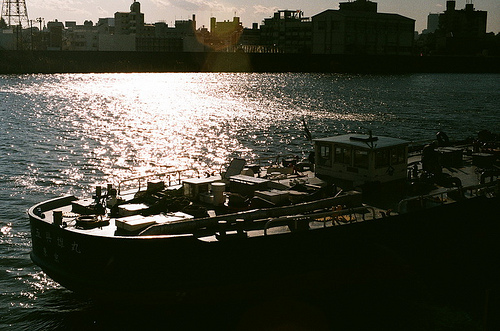Is the man sitting on a bench? The image doesn’t show any individual sitting on a bench; in fact, there are no visible benches or people in the immediate scenery. 